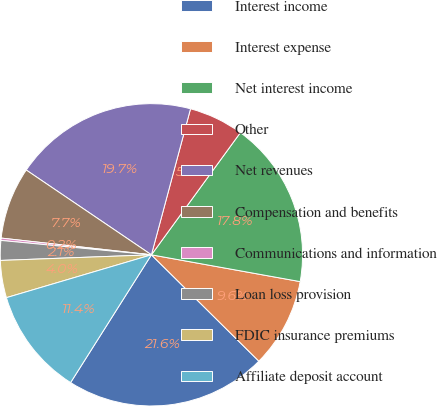Convert chart. <chart><loc_0><loc_0><loc_500><loc_500><pie_chart><fcel>Interest income<fcel>Interest expense<fcel>Net interest income<fcel>Other<fcel>Net revenues<fcel>Compensation and benefits<fcel>Communications and information<fcel>Loan loss provision<fcel>FDIC insurance premiums<fcel>Affiliate deposit account<nl><fcel>21.56%<fcel>9.58%<fcel>17.82%<fcel>5.85%<fcel>19.69%<fcel>7.71%<fcel>0.25%<fcel>2.11%<fcel>3.98%<fcel>11.45%<nl></chart> 